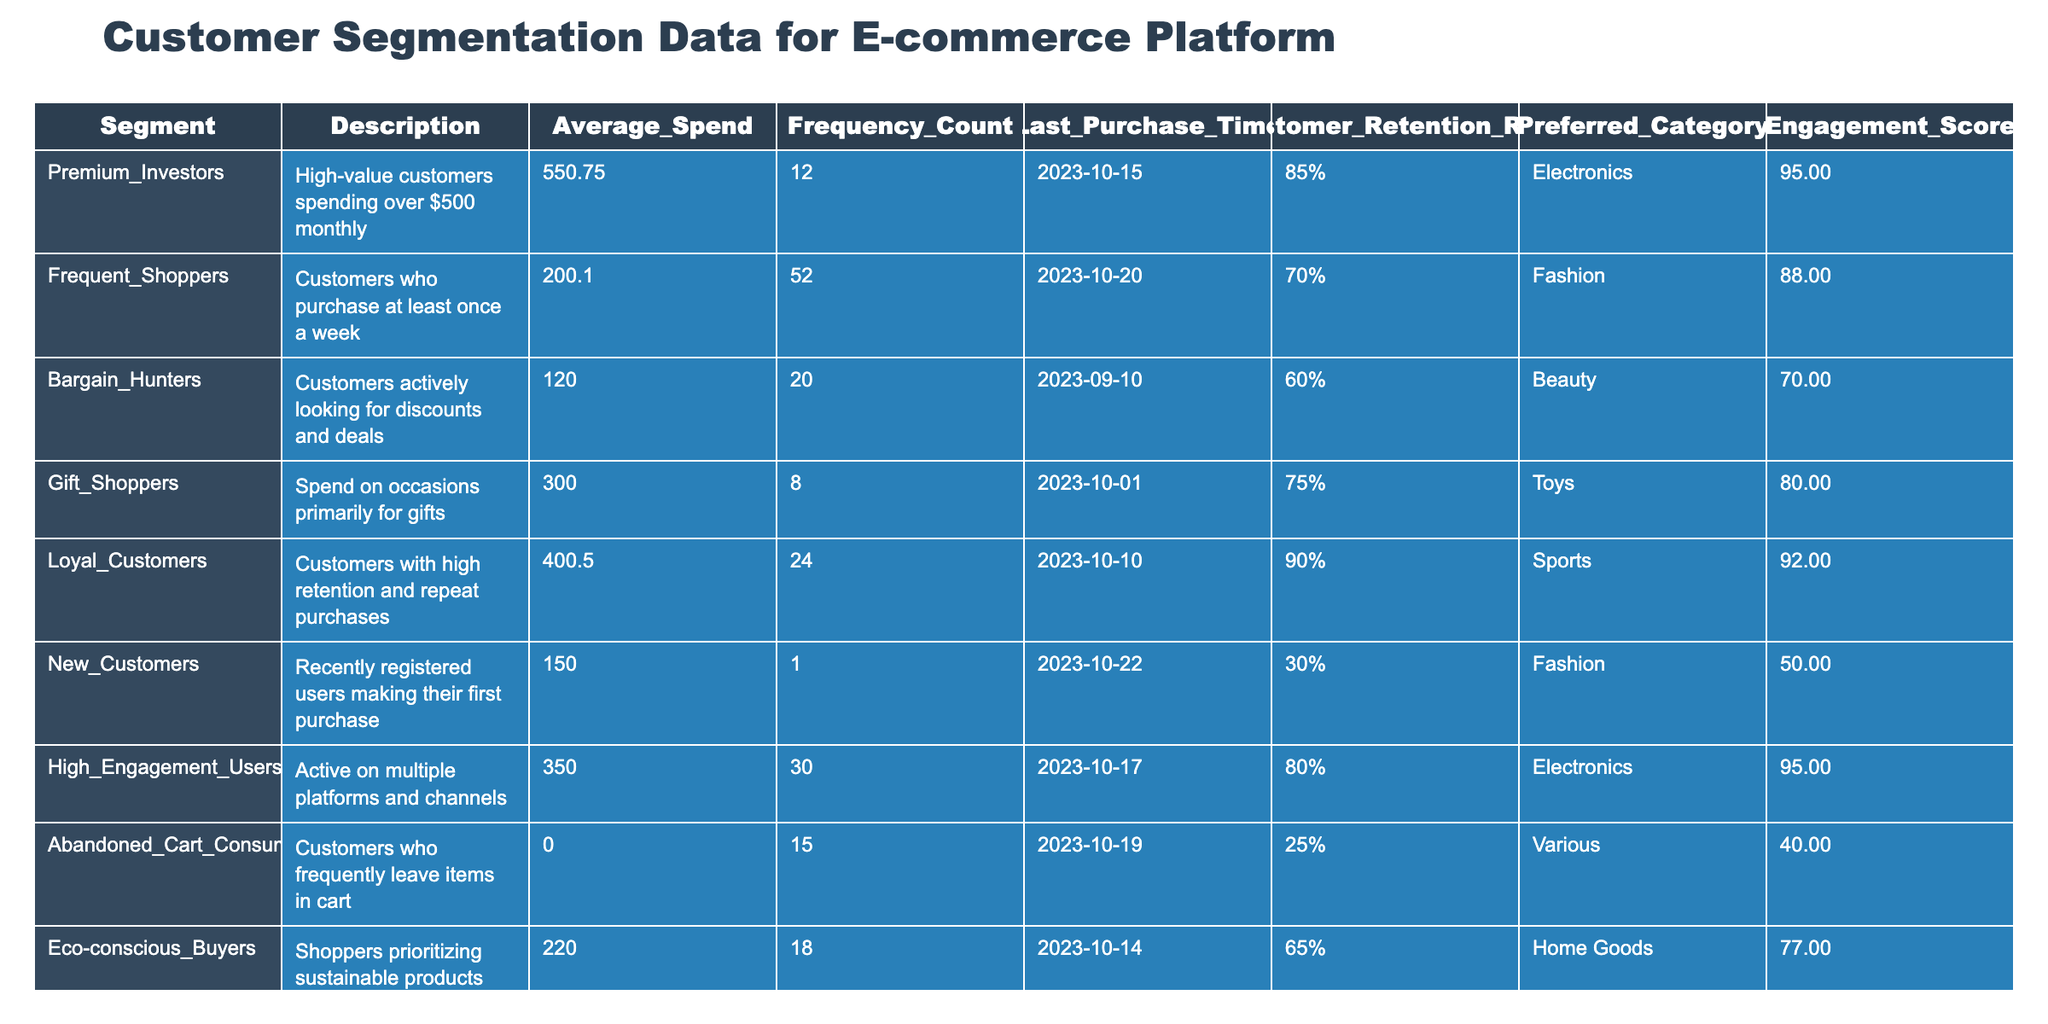What is the Average Spend for the Premium Investors segment? The table shows that the Average Spend for the Premium Investors segment is listed as 550.75.
Answer: 550.75 Which segment has the highest Engagement Score? Looking through the Engagement Score column, I find that both Premium Investors and High Engagement Users have the highest score of 95.
Answer: 95 What is the Customer Retention Rate for New Customers? The table specifies that the Customer Retention Rate for New Customers is 30%, indicated in the respective column.
Answer: 30% How many customers are classified as Frequent Shoppers? The Frequency Count for the Frequent Shoppers segment is 52, which indicates there are 52 customers in that category.
Answer: 52 If we add up the Average Spend of Bargain Hunters and Gift Shoppers, what total do we get? The Average Spend for Bargain Hunters is 120.00 and for Gift Shoppers, it is 300.00. Adding these two amounts gives 120 + 300 = 420.
Answer: 420 Is the Average Spend for Eco-conscious Buyers greater than that of Abandoned Cart Consumers? The Average Spend for Eco-conscious Buyers is 220.00 and for Abandoned Cart Consumers, it is 0.00. Since 220.00 is greater than 0.00, the statement is true.
Answer: Yes Which segment has the lowest Customer Retention Rate? By comparing the Customer Retention Rates, I see that Abandoned Cart Consumers have the lowest rate at 25%, when looking at the entire table.
Answer: 25% What is the difference in Average Spend between Tech Enthusiasts and Frequent Shoppers? The Average Spend for Tech Enthusiasts is 500.00 and for Frequent Shoppers is 200.10. The difference is calculated as 500.00 - 200.10 = 299.90.
Answer: 299.90 What percentage of customers in the Loyal Customers segment have a Customer Retention Rate of 90% or higher? Only the Loyal Customers segment has a Customer Retention Rate of 90%, equating to a single segment out of the total 10 segments. Therefore, the percentage is (1/10) * 100 = 10%.
Answer: 10% 